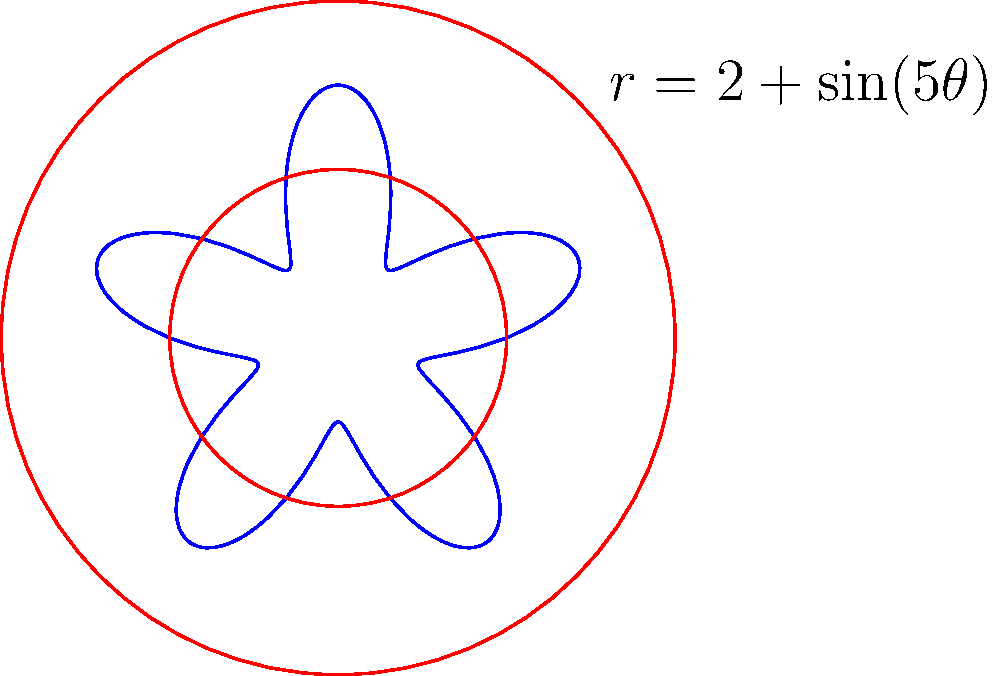In the context of creating a circular mandala design to represent interfaith harmony, consider the polar equation $r = 2 + \sin(5\theta)$. How many petals or lobes does this design create, symbolizing the number of major faith traditions coming together in unity? To determine the number of petals or lobes in this mandala design, we need to analyze the given polar equation:

1. The equation is $r = 2 + \sin(5\theta)$
2. The sine function repeats every $2\pi$ radians
3. In this case, the argument of sine is $5\theta$
4. For the design to complete one full cycle, we need:
   $5\theta = 2\pi$
5. Solving for $\theta$:
   $\theta = \frac{2\pi}{5}$
6. This means the pattern repeats 5 times in a full $2\pi$ rotation
7. Each repetition creates one petal or lobe
8. Therefore, the design has 5 petals or lobes

These 5 petals can symbolize five major world religions or spiritual traditions coming together in harmony, such as Islam, Christianity, Judaism, Hinduism, and Buddhism, reflecting the Sufi ideal of unity in diversity.
Answer: 5 petals 